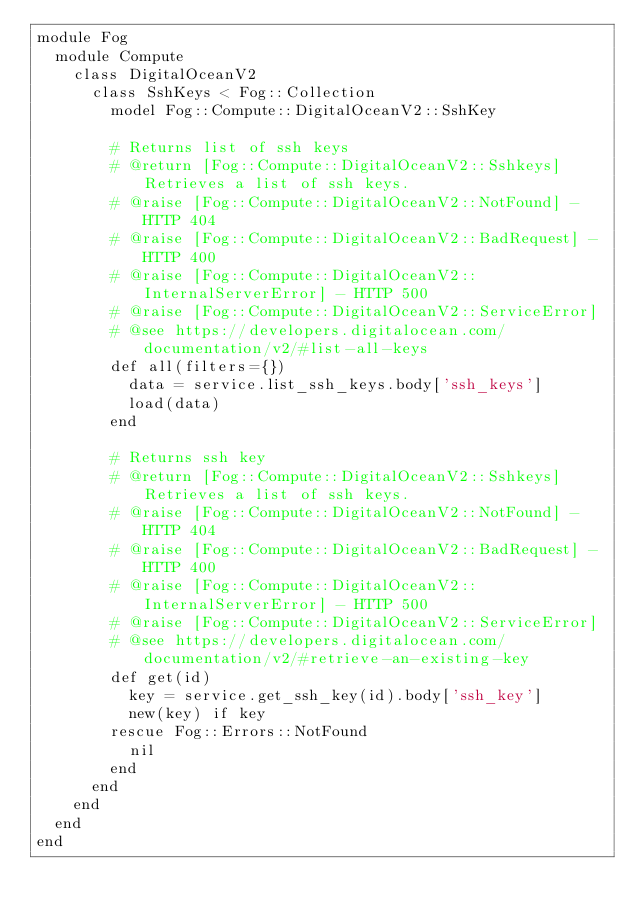<code> <loc_0><loc_0><loc_500><loc_500><_Ruby_>module Fog
  module Compute
    class DigitalOceanV2
      class SshKeys < Fog::Collection
        model Fog::Compute::DigitalOceanV2::SshKey

        # Returns list of ssh keys
        # @return [Fog::Compute::DigitalOceanV2::Sshkeys] Retrieves a list of ssh keys.
        # @raise [Fog::Compute::DigitalOceanV2::NotFound] - HTTP 404
        # @raise [Fog::Compute::DigitalOceanV2::BadRequest] - HTTP 400
        # @raise [Fog::Compute::DigitalOceanV2::InternalServerError] - HTTP 500
        # @raise [Fog::Compute::DigitalOceanV2::ServiceError]
        # @see https://developers.digitalocean.com/documentation/v2/#list-all-keys
        def all(filters={})
          data = service.list_ssh_keys.body['ssh_keys']
          load(data)
        end

        # Returns ssh key
        # @return [Fog::Compute::DigitalOceanV2::Sshkeys] Retrieves a list of ssh keys.
        # @raise [Fog::Compute::DigitalOceanV2::NotFound] - HTTP 404
        # @raise [Fog::Compute::DigitalOceanV2::BadRequest] - HTTP 400
        # @raise [Fog::Compute::DigitalOceanV2::InternalServerError] - HTTP 500
        # @raise [Fog::Compute::DigitalOceanV2::ServiceError]
        # @see https://developers.digitalocean.com/documentation/v2/#retrieve-an-existing-key
        def get(id)
          key = service.get_ssh_key(id).body['ssh_key']
          new(key) if key
        rescue Fog::Errors::NotFound
          nil
        end
      end
    end
  end
end</code> 